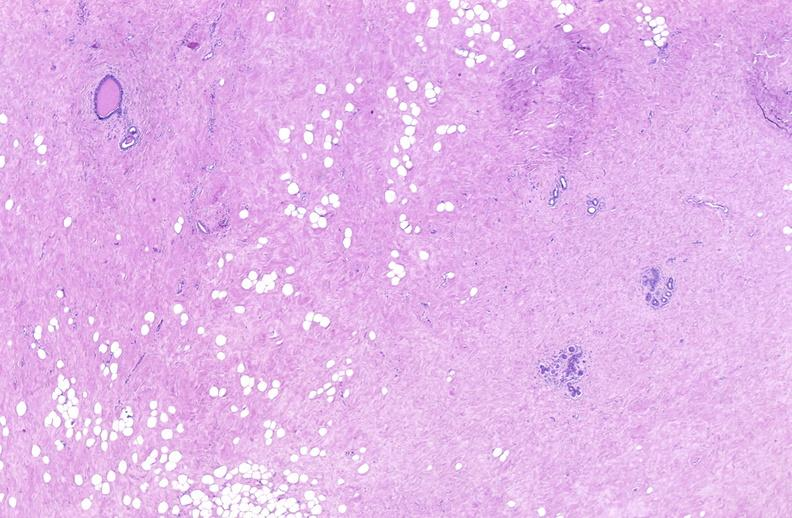does this image show breast, fibroadenoma?
Answer the question using a single word or phrase. Yes 